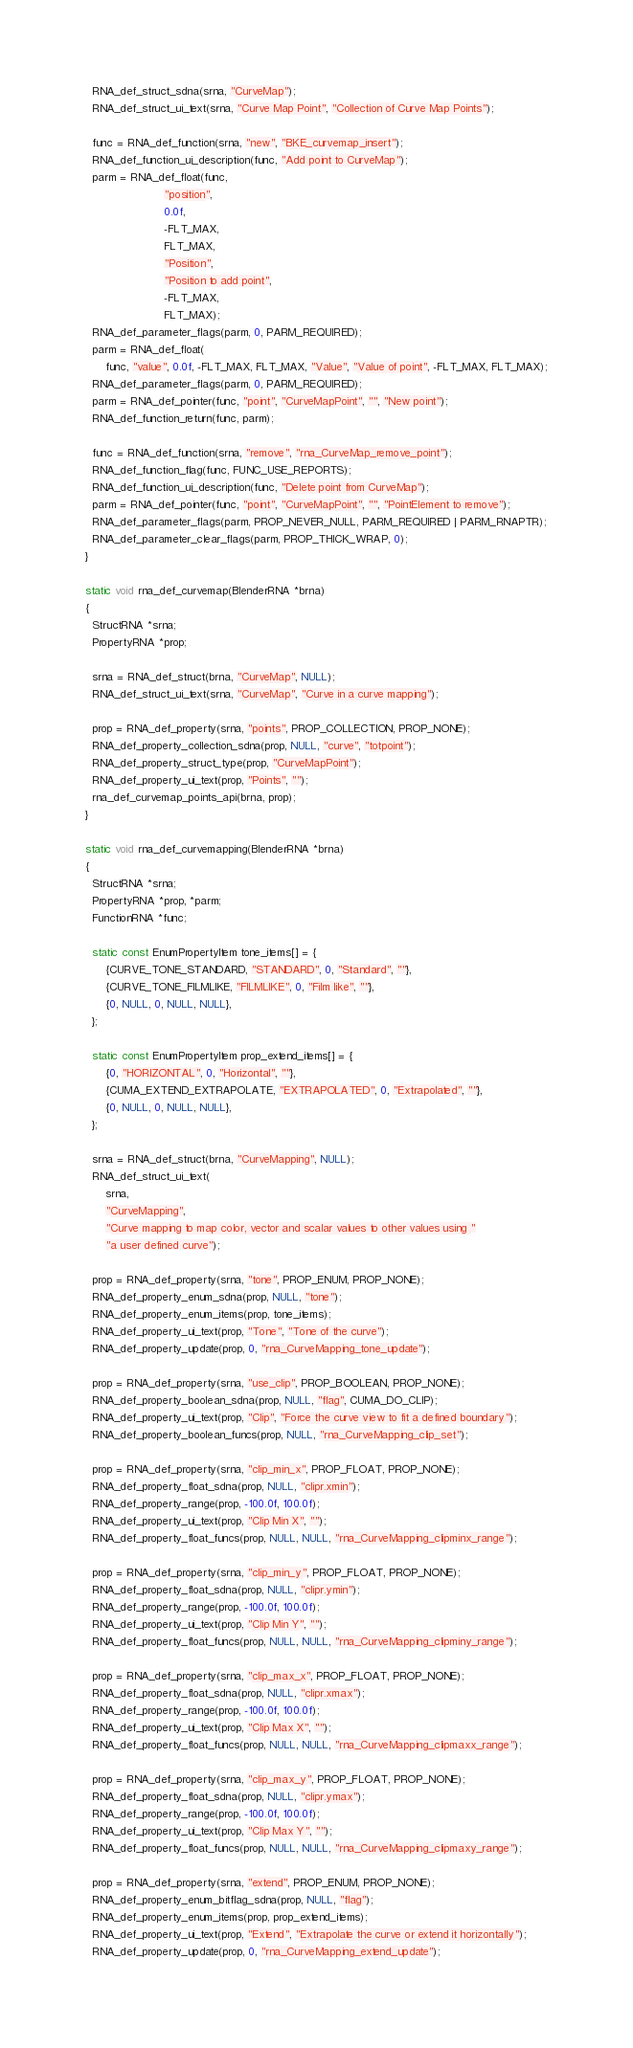Convert code to text. <code><loc_0><loc_0><loc_500><loc_500><_C_>  RNA_def_struct_sdna(srna, "CurveMap");
  RNA_def_struct_ui_text(srna, "Curve Map Point", "Collection of Curve Map Points");

  func = RNA_def_function(srna, "new", "BKE_curvemap_insert");
  RNA_def_function_ui_description(func, "Add point to CurveMap");
  parm = RNA_def_float(func,
                       "position",
                       0.0f,
                       -FLT_MAX,
                       FLT_MAX,
                       "Position",
                       "Position to add point",
                       -FLT_MAX,
                       FLT_MAX);
  RNA_def_parameter_flags(parm, 0, PARM_REQUIRED);
  parm = RNA_def_float(
      func, "value", 0.0f, -FLT_MAX, FLT_MAX, "Value", "Value of point", -FLT_MAX, FLT_MAX);
  RNA_def_parameter_flags(parm, 0, PARM_REQUIRED);
  parm = RNA_def_pointer(func, "point", "CurveMapPoint", "", "New point");
  RNA_def_function_return(func, parm);

  func = RNA_def_function(srna, "remove", "rna_CurveMap_remove_point");
  RNA_def_function_flag(func, FUNC_USE_REPORTS);
  RNA_def_function_ui_description(func, "Delete point from CurveMap");
  parm = RNA_def_pointer(func, "point", "CurveMapPoint", "", "PointElement to remove");
  RNA_def_parameter_flags(parm, PROP_NEVER_NULL, PARM_REQUIRED | PARM_RNAPTR);
  RNA_def_parameter_clear_flags(parm, PROP_THICK_WRAP, 0);
}

static void rna_def_curvemap(BlenderRNA *brna)
{
  StructRNA *srna;
  PropertyRNA *prop;

  srna = RNA_def_struct(brna, "CurveMap", NULL);
  RNA_def_struct_ui_text(srna, "CurveMap", "Curve in a curve mapping");

  prop = RNA_def_property(srna, "points", PROP_COLLECTION, PROP_NONE);
  RNA_def_property_collection_sdna(prop, NULL, "curve", "totpoint");
  RNA_def_property_struct_type(prop, "CurveMapPoint");
  RNA_def_property_ui_text(prop, "Points", "");
  rna_def_curvemap_points_api(brna, prop);
}

static void rna_def_curvemapping(BlenderRNA *brna)
{
  StructRNA *srna;
  PropertyRNA *prop, *parm;
  FunctionRNA *func;

  static const EnumPropertyItem tone_items[] = {
      {CURVE_TONE_STANDARD, "STANDARD", 0, "Standard", ""},
      {CURVE_TONE_FILMLIKE, "FILMLIKE", 0, "Film like", ""},
      {0, NULL, 0, NULL, NULL},
  };

  static const EnumPropertyItem prop_extend_items[] = {
      {0, "HORIZONTAL", 0, "Horizontal", ""},
      {CUMA_EXTEND_EXTRAPOLATE, "EXTRAPOLATED", 0, "Extrapolated", ""},
      {0, NULL, 0, NULL, NULL},
  };

  srna = RNA_def_struct(brna, "CurveMapping", NULL);
  RNA_def_struct_ui_text(
      srna,
      "CurveMapping",
      "Curve mapping to map color, vector and scalar values to other values using "
      "a user defined curve");

  prop = RNA_def_property(srna, "tone", PROP_ENUM, PROP_NONE);
  RNA_def_property_enum_sdna(prop, NULL, "tone");
  RNA_def_property_enum_items(prop, tone_items);
  RNA_def_property_ui_text(prop, "Tone", "Tone of the curve");
  RNA_def_property_update(prop, 0, "rna_CurveMapping_tone_update");

  prop = RNA_def_property(srna, "use_clip", PROP_BOOLEAN, PROP_NONE);
  RNA_def_property_boolean_sdna(prop, NULL, "flag", CUMA_DO_CLIP);
  RNA_def_property_ui_text(prop, "Clip", "Force the curve view to fit a defined boundary");
  RNA_def_property_boolean_funcs(prop, NULL, "rna_CurveMapping_clip_set");

  prop = RNA_def_property(srna, "clip_min_x", PROP_FLOAT, PROP_NONE);
  RNA_def_property_float_sdna(prop, NULL, "clipr.xmin");
  RNA_def_property_range(prop, -100.0f, 100.0f);
  RNA_def_property_ui_text(prop, "Clip Min X", "");
  RNA_def_property_float_funcs(prop, NULL, NULL, "rna_CurveMapping_clipminx_range");

  prop = RNA_def_property(srna, "clip_min_y", PROP_FLOAT, PROP_NONE);
  RNA_def_property_float_sdna(prop, NULL, "clipr.ymin");
  RNA_def_property_range(prop, -100.0f, 100.0f);
  RNA_def_property_ui_text(prop, "Clip Min Y", "");
  RNA_def_property_float_funcs(prop, NULL, NULL, "rna_CurveMapping_clipminy_range");

  prop = RNA_def_property(srna, "clip_max_x", PROP_FLOAT, PROP_NONE);
  RNA_def_property_float_sdna(prop, NULL, "clipr.xmax");
  RNA_def_property_range(prop, -100.0f, 100.0f);
  RNA_def_property_ui_text(prop, "Clip Max X", "");
  RNA_def_property_float_funcs(prop, NULL, NULL, "rna_CurveMapping_clipmaxx_range");

  prop = RNA_def_property(srna, "clip_max_y", PROP_FLOAT, PROP_NONE);
  RNA_def_property_float_sdna(prop, NULL, "clipr.ymax");
  RNA_def_property_range(prop, -100.0f, 100.0f);
  RNA_def_property_ui_text(prop, "Clip Max Y", "");
  RNA_def_property_float_funcs(prop, NULL, NULL, "rna_CurveMapping_clipmaxy_range");

  prop = RNA_def_property(srna, "extend", PROP_ENUM, PROP_NONE);
  RNA_def_property_enum_bitflag_sdna(prop, NULL, "flag");
  RNA_def_property_enum_items(prop, prop_extend_items);
  RNA_def_property_ui_text(prop, "Extend", "Extrapolate the curve or extend it horizontally");
  RNA_def_property_update(prop, 0, "rna_CurveMapping_extend_update");
</code> 